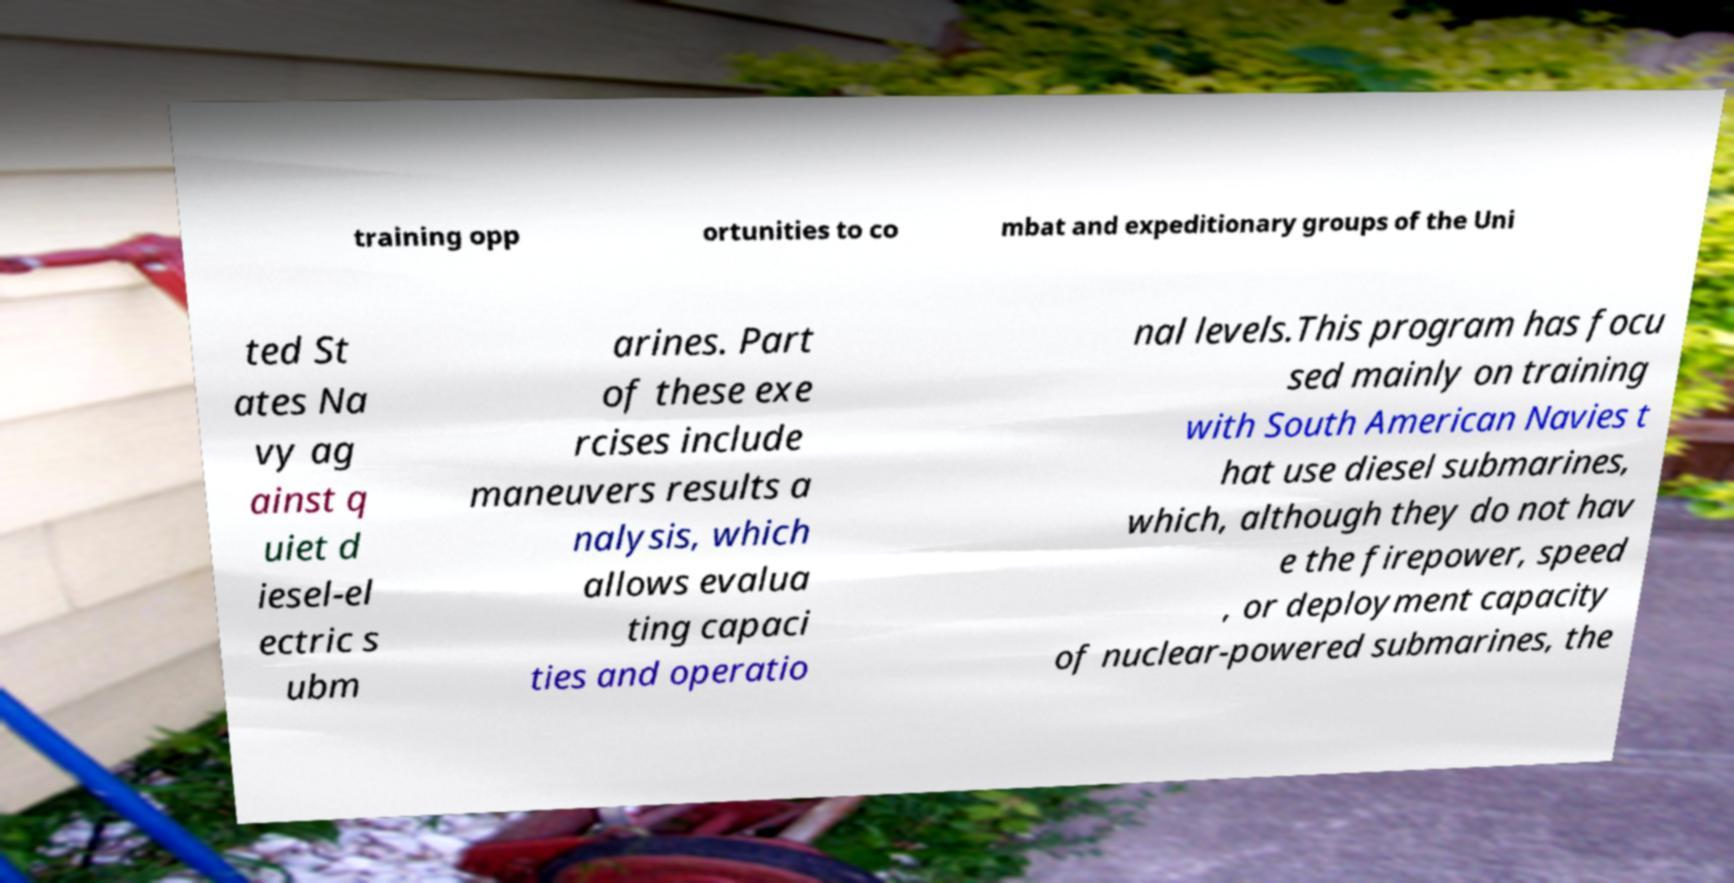Could you extract and type out the text from this image? training opp ortunities to co mbat and expeditionary groups of the Uni ted St ates Na vy ag ainst q uiet d iesel-el ectric s ubm arines. Part of these exe rcises include maneuvers results a nalysis, which allows evalua ting capaci ties and operatio nal levels.This program has focu sed mainly on training with South American Navies t hat use diesel submarines, which, although they do not hav e the firepower, speed , or deployment capacity of nuclear-powered submarines, the 